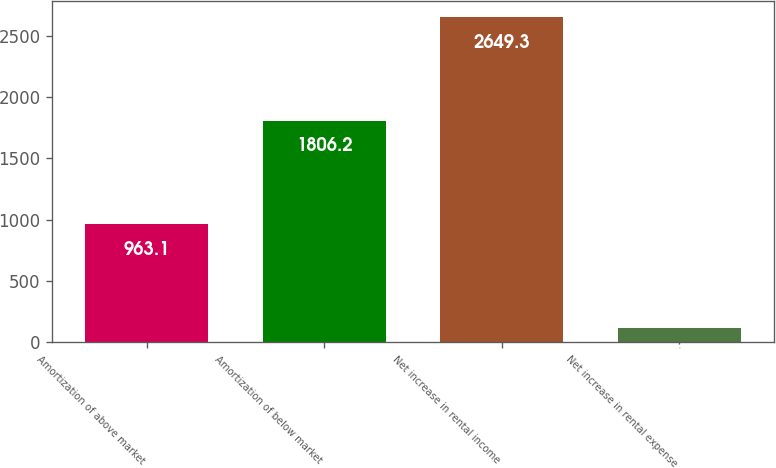Convert chart to OTSL. <chart><loc_0><loc_0><loc_500><loc_500><bar_chart><fcel>Amortization of above market<fcel>Amortization of below market<fcel>Net increase in rental income<fcel>Net increase in rental expense<nl><fcel>963.1<fcel>1806.2<fcel>2649.3<fcel>120<nl></chart> 